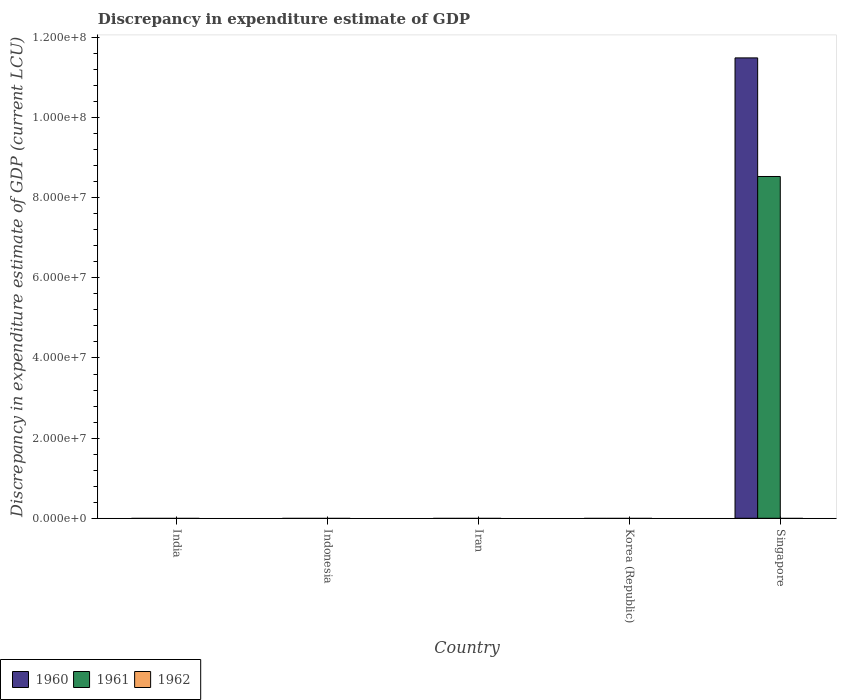How many different coloured bars are there?
Offer a terse response. 2. Are the number of bars per tick equal to the number of legend labels?
Ensure brevity in your answer.  No. How many bars are there on the 5th tick from the left?
Your answer should be very brief. 2. What is the discrepancy in expenditure estimate of GDP in 1961 in Indonesia?
Your answer should be very brief. 0. Across all countries, what is the maximum discrepancy in expenditure estimate of GDP in 1961?
Your answer should be compact. 8.53e+07. Across all countries, what is the minimum discrepancy in expenditure estimate of GDP in 1960?
Your response must be concise. 0. In which country was the discrepancy in expenditure estimate of GDP in 1961 maximum?
Offer a very short reply. Singapore. What is the total discrepancy in expenditure estimate of GDP in 1961 in the graph?
Offer a terse response. 8.53e+07. What is the average discrepancy in expenditure estimate of GDP in 1960 per country?
Your answer should be very brief. 2.30e+07. What is the difference between the discrepancy in expenditure estimate of GDP of/in 1960 and discrepancy in expenditure estimate of GDP of/in 1961 in Singapore?
Offer a terse response. 2.96e+07. What is the difference between the highest and the lowest discrepancy in expenditure estimate of GDP in 1961?
Your answer should be very brief. 8.53e+07. In how many countries, is the discrepancy in expenditure estimate of GDP in 1961 greater than the average discrepancy in expenditure estimate of GDP in 1961 taken over all countries?
Offer a very short reply. 1. Are all the bars in the graph horizontal?
Keep it short and to the point. No. Does the graph contain grids?
Keep it short and to the point. No. How many legend labels are there?
Provide a succinct answer. 3. How are the legend labels stacked?
Offer a terse response. Horizontal. What is the title of the graph?
Ensure brevity in your answer.  Discrepancy in expenditure estimate of GDP. Does "1965" appear as one of the legend labels in the graph?
Your response must be concise. No. What is the label or title of the Y-axis?
Your response must be concise. Discrepancy in expenditure estimate of GDP (current LCU). What is the Discrepancy in expenditure estimate of GDP (current LCU) of 1961 in India?
Provide a short and direct response. 0. What is the Discrepancy in expenditure estimate of GDP (current LCU) of 1960 in Iran?
Your answer should be compact. 0. What is the Discrepancy in expenditure estimate of GDP (current LCU) in 1962 in Iran?
Your answer should be compact. 0. What is the Discrepancy in expenditure estimate of GDP (current LCU) of 1960 in Korea (Republic)?
Keep it short and to the point. 0. What is the Discrepancy in expenditure estimate of GDP (current LCU) in 1962 in Korea (Republic)?
Ensure brevity in your answer.  0. What is the Discrepancy in expenditure estimate of GDP (current LCU) of 1960 in Singapore?
Ensure brevity in your answer.  1.15e+08. What is the Discrepancy in expenditure estimate of GDP (current LCU) of 1961 in Singapore?
Give a very brief answer. 8.53e+07. What is the Discrepancy in expenditure estimate of GDP (current LCU) of 1962 in Singapore?
Your answer should be very brief. 0. Across all countries, what is the maximum Discrepancy in expenditure estimate of GDP (current LCU) in 1960?
Ensure brevity in your answer.  1.15e+08. Across all countries, what is the maximum Discrepancy in expenditure estimate of GDP (current LCU) of 1961?
Keep it short and to the point. 8.53e+07. Across all countries, what is the minimum Discrepancy in expenditure estimate of GDP (current LCU) of 1961?
Provide a short and direct response. 0. What is the total Discrepancy in expenditure estimate of GDP (current LCU) in 1960 in the graph?
Ensure brevity in your answer.  1.15e+08. What is the total Discrepancy in expenditure estimate of GDP (current LCU) of 1961 in the graph?
Your answer should be compact. 8.53e+07. What is the total Discrepancy in expenditure estimate of GDP (current LCU) in 1962 in the graph?
Offer a terse response. 0. What is the average Discrepancy in expenditure estimate of GDP (current LCU) in 1960 per country?
Make the answer very short. 2.30e+07. What is the average Discrepancy in expenditure estimate of GDP (current LCU) in 1961 per country?
Your response must be concise. 1.71e+07. What is the average Discrepancy in expenditure estimate of GDP (current LCU) of 1962 per country?
Offer a very short reply. 0. What is the difference between the Discrepancy in expenditure estimate of GDP (current LCU) of 1960 and Discrepancy in expenditure estimate of GDP (current LCU) of 1961 in Singapore?
Make the answer very short. 2.96e+07. What is the difference between the highest and the lowest Discrepancy in expenditure estimate of GDP (current LCU) in 1960?
Your answer should be compact. 1.15e+08. What is the difference between the highest and the lowest Discrepancy in expenditure estimate of GDP (current LCU) in 1961?
Keep it short and to the point. 8.53e+07. 